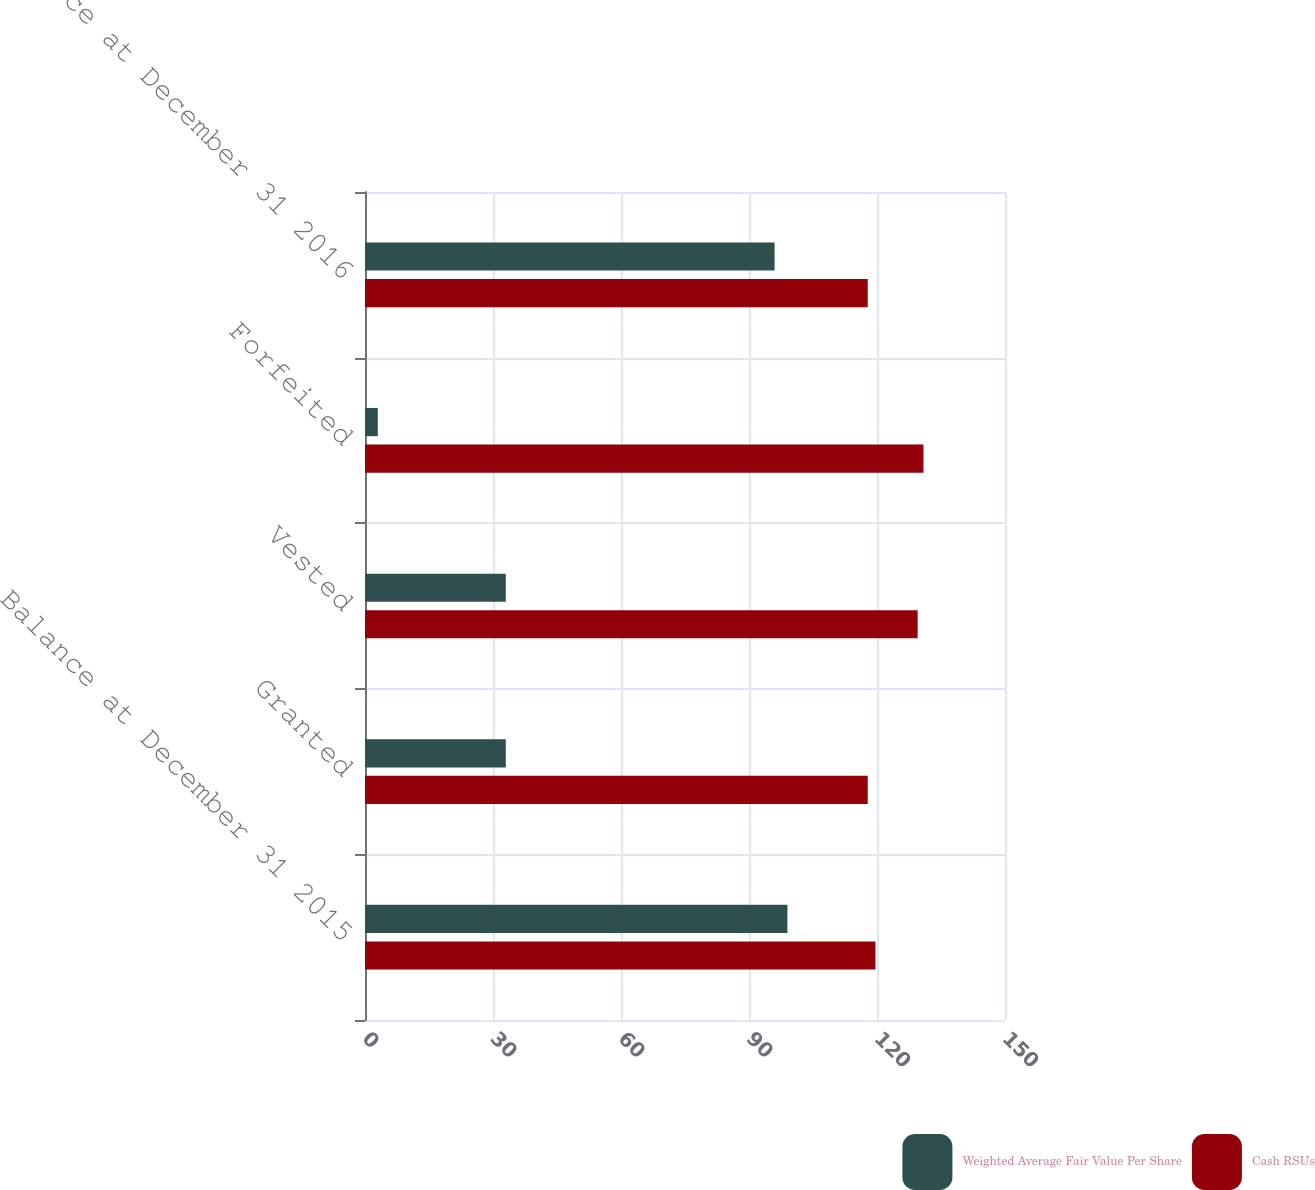Convert chart to OTSL. <chart><loc_0><loc_0><loc_500><loc_500><stacked_bar_chart><ecel><fcel>Balance at December 31 2015<fcel>Granted<fcel>Vested<fcel>Forfeited<fcel>Balance at December 31 2016<nl><fcel>Weighted Average Fair Value Per Share<fcel>99<fcel>33<fcel>33<fcel>3<fcel>96<nl><fcel>Cash RSUs<fcel>119.64<fcel>117.83<fcel>129.53<fcel>130.89<fcel>117.83<nl></chart> 